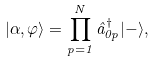Convert formula to latex. <formula><loc_0><loc_0><loc_500><loc_500>| \alpha , \varphi \rangle = \prod _ { p = 1 } ^ { N } \hat { a } _ { 0 p } ^ { \dagger } | - \rangle ,</formula> 